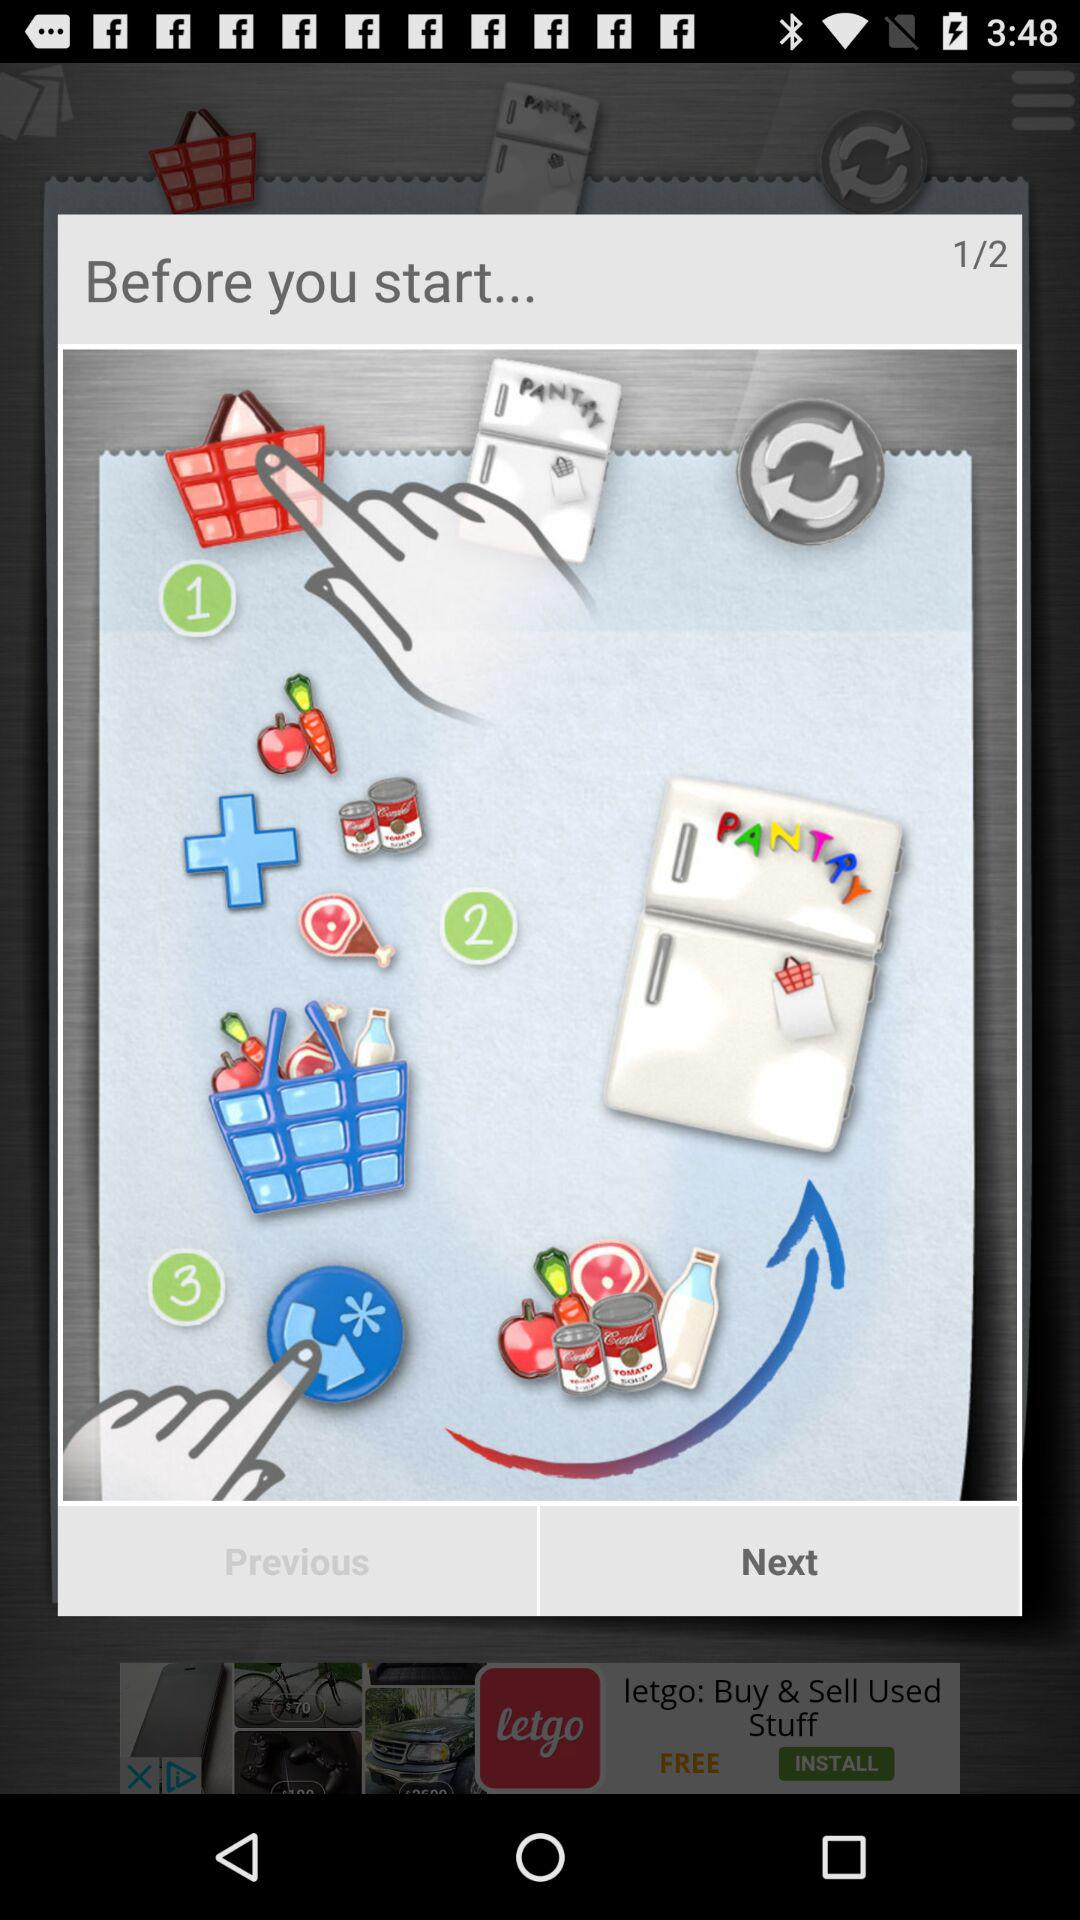How many green circles are there with a number in them?
Answer the question using a single word or phrase. 3 